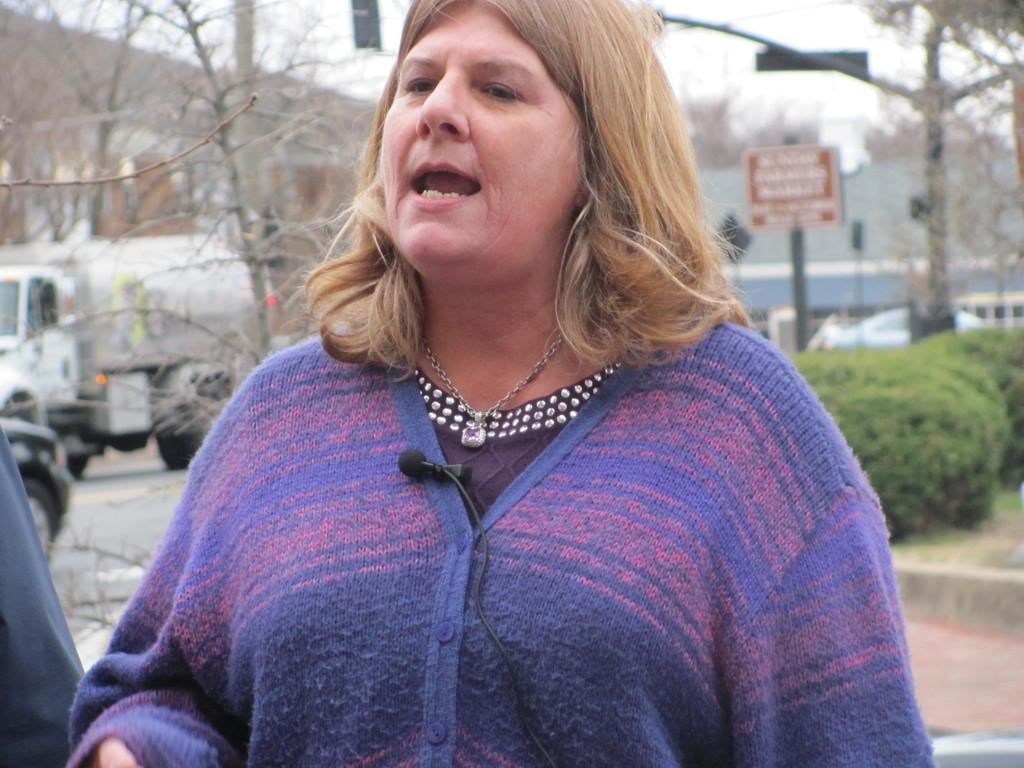Who is present in the image? There is a woman in the image. What can be seen in the background of the image? In the background of the image, there are plants, poles, boards, vehicles, trees, buildings, and the sky. What language is the woman speaking in the image? There is no indication of the woman speaking in the image, nor is there any information about the language she might be speaking. 